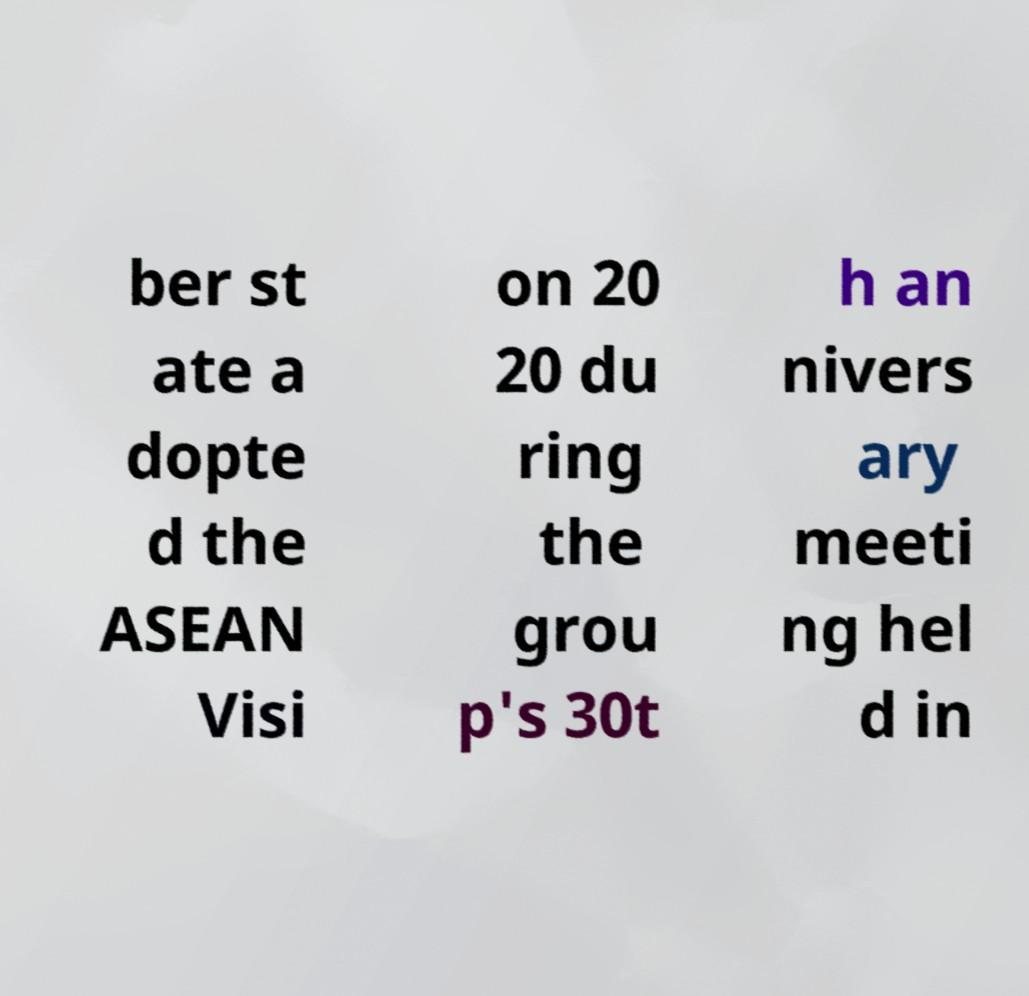For documentation purposes, I need the text within this image transcribed. Could you provide that? ber st ate a dopte d the ASEAN Visi on 20 20 du ring the grou p's 30t h an nivers ary meeti ng hel d in 